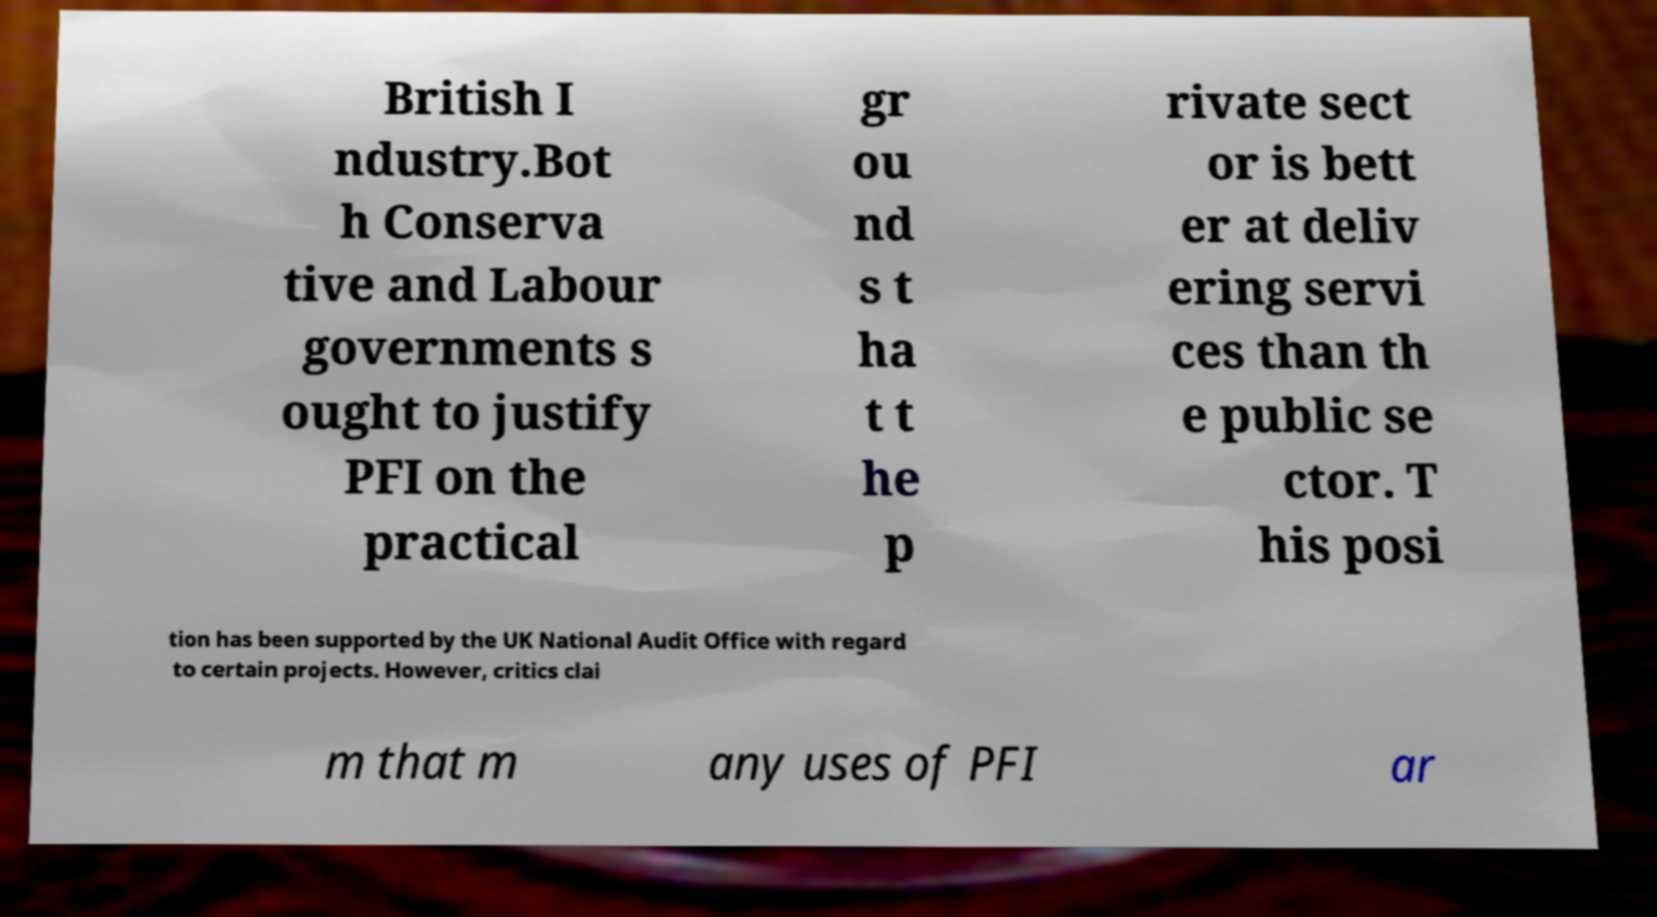Can you read and provide the text displayed in the image?This photo seems to have some interesting text. Can you extract and type it out for me? British I ndustry.Bot h Conserva tive and Labour governments s ought to justify PFI on the practical gr ou nd s t ha t t he p rivate sect or is bett er at deliv ering servi ces than th e public se ctor. T his posi tion has been supported by the UK National Audit Office with regard to certain projects. However, critics clai m that m any uses of PFI ar 